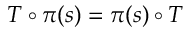<formula> <loc_0><loc_0><loc_500><loc_500>T \circ \pi ( s ) = \pi ( s ) \circ T</formula> 